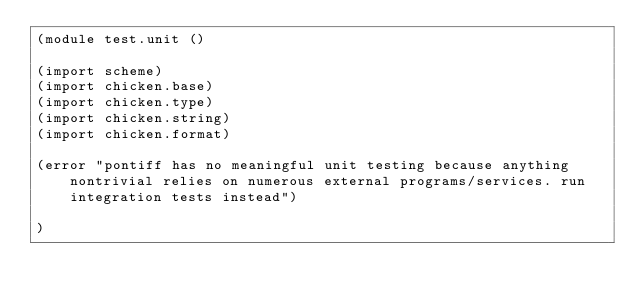Convert code to text. <code><loc_0><loc_0><loc_500><loc_500><_Scheme_>(module test.unit ()

(import scheme)
(import chicken.base)
(import chicken.type)
(import chicken.string)
(import chicken.format)

(error "pontiff has no meaningful unit testing because anything nontrivial relies on numerous external programs/services. run integration tests instead")

)
</code> 